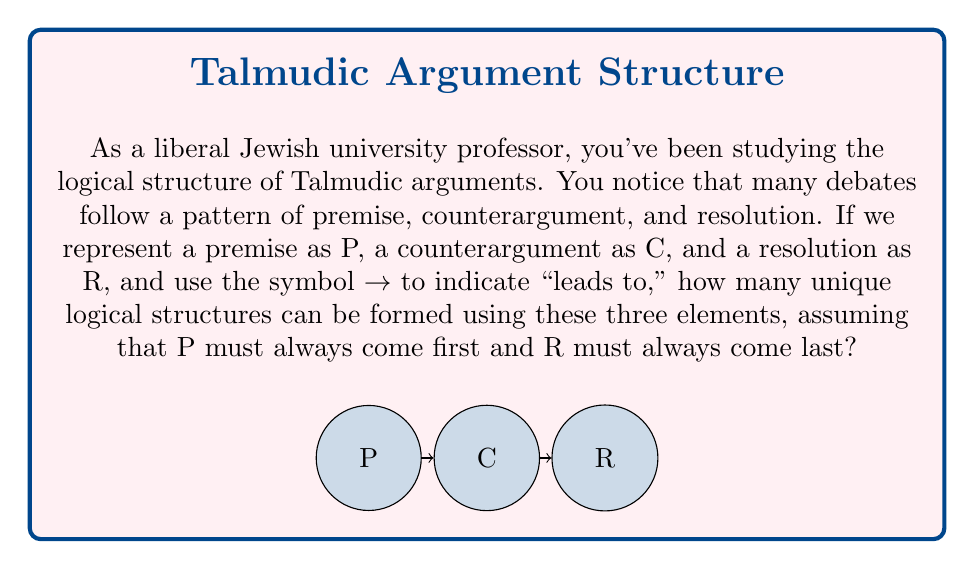Could you help me with this problem? Let's approach this step-by-step:

1) We know that P must always be first and R must always be last. So our structures will always start with P and end with R.

2) The question then becomes: where can C be placed in relation to P and R?

3) There are three possibilities:
   a) P → C → R
   b) P → R (C is not used)
   c) P → C → C → R (C is used twice)

4) We can't have more than two C's because that would create a cycle or an infinite loop, which is not logically sound in Talmudic reasoning.

5) We can represent these possibilities mathematically:
   Let $n$ be the number of possible positions for C.
   Then, the number of unique structures is given by the sum of combinations:
   
   $$ \sum_{k=0}^2 \binom{n}{k} $$

   Where $n = 2$ (the two possible positions for C: after P or before R)

6) Calculating:
   $\binom{2}{0} + \binom{2}{1} + \binom{2}{2} = 1 + 2 + 1 = 4$

Therefore, there are 4 unique logical structures possible.
Answer: 4 